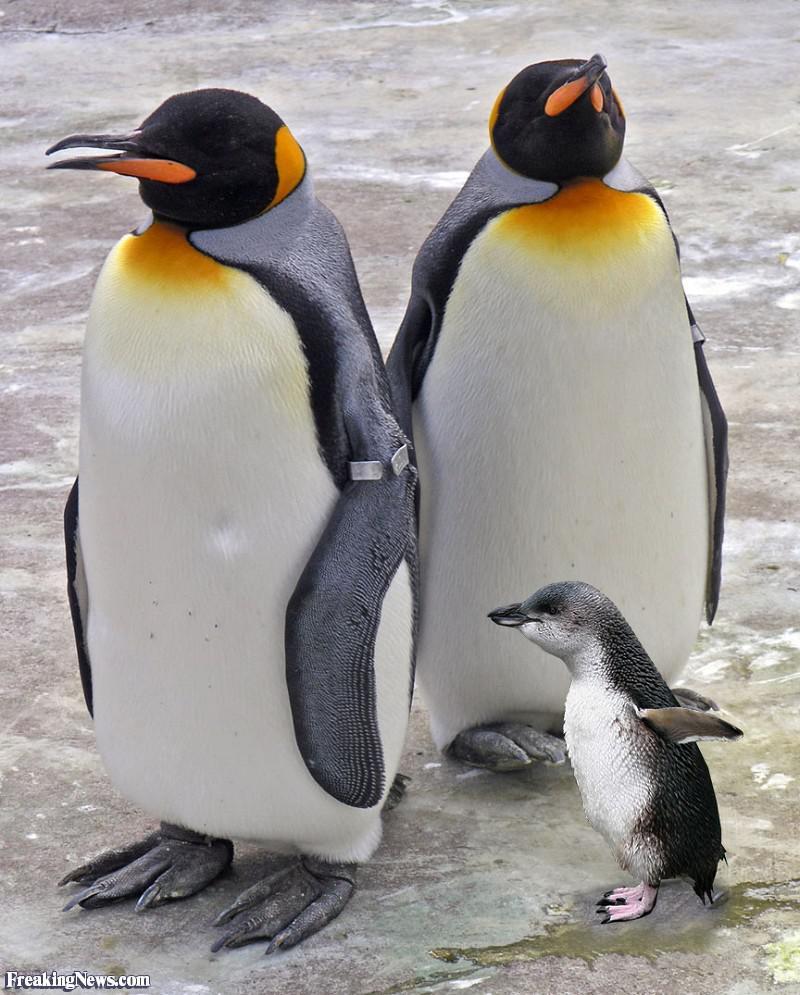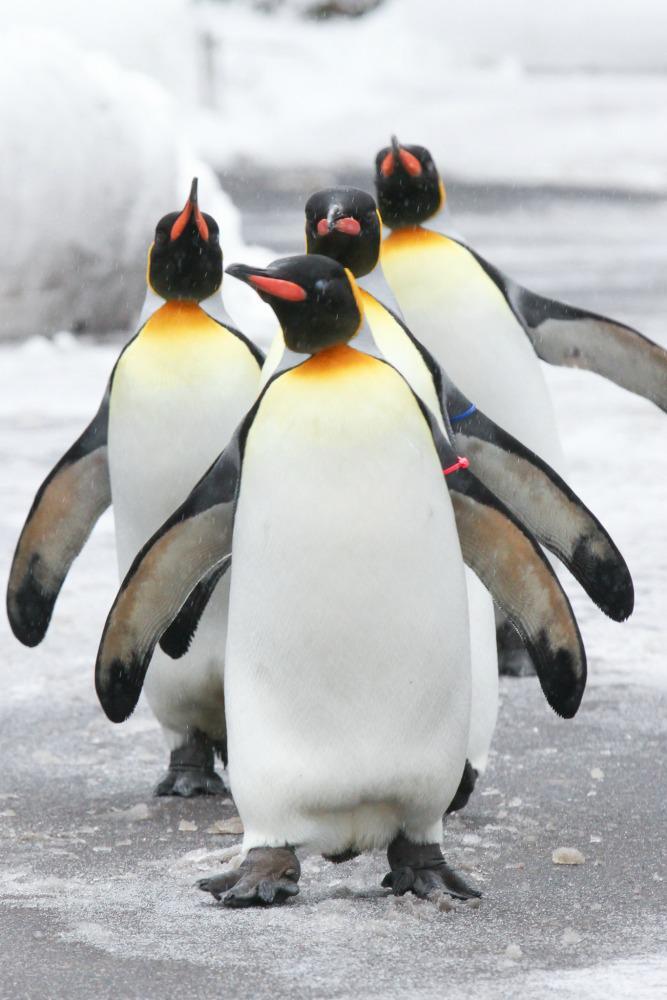The first image is the image on the left, the second image is the image on the right. For the images displayed, is the sentence "There are two penguins" factually correct? Answer yes or no. No. 